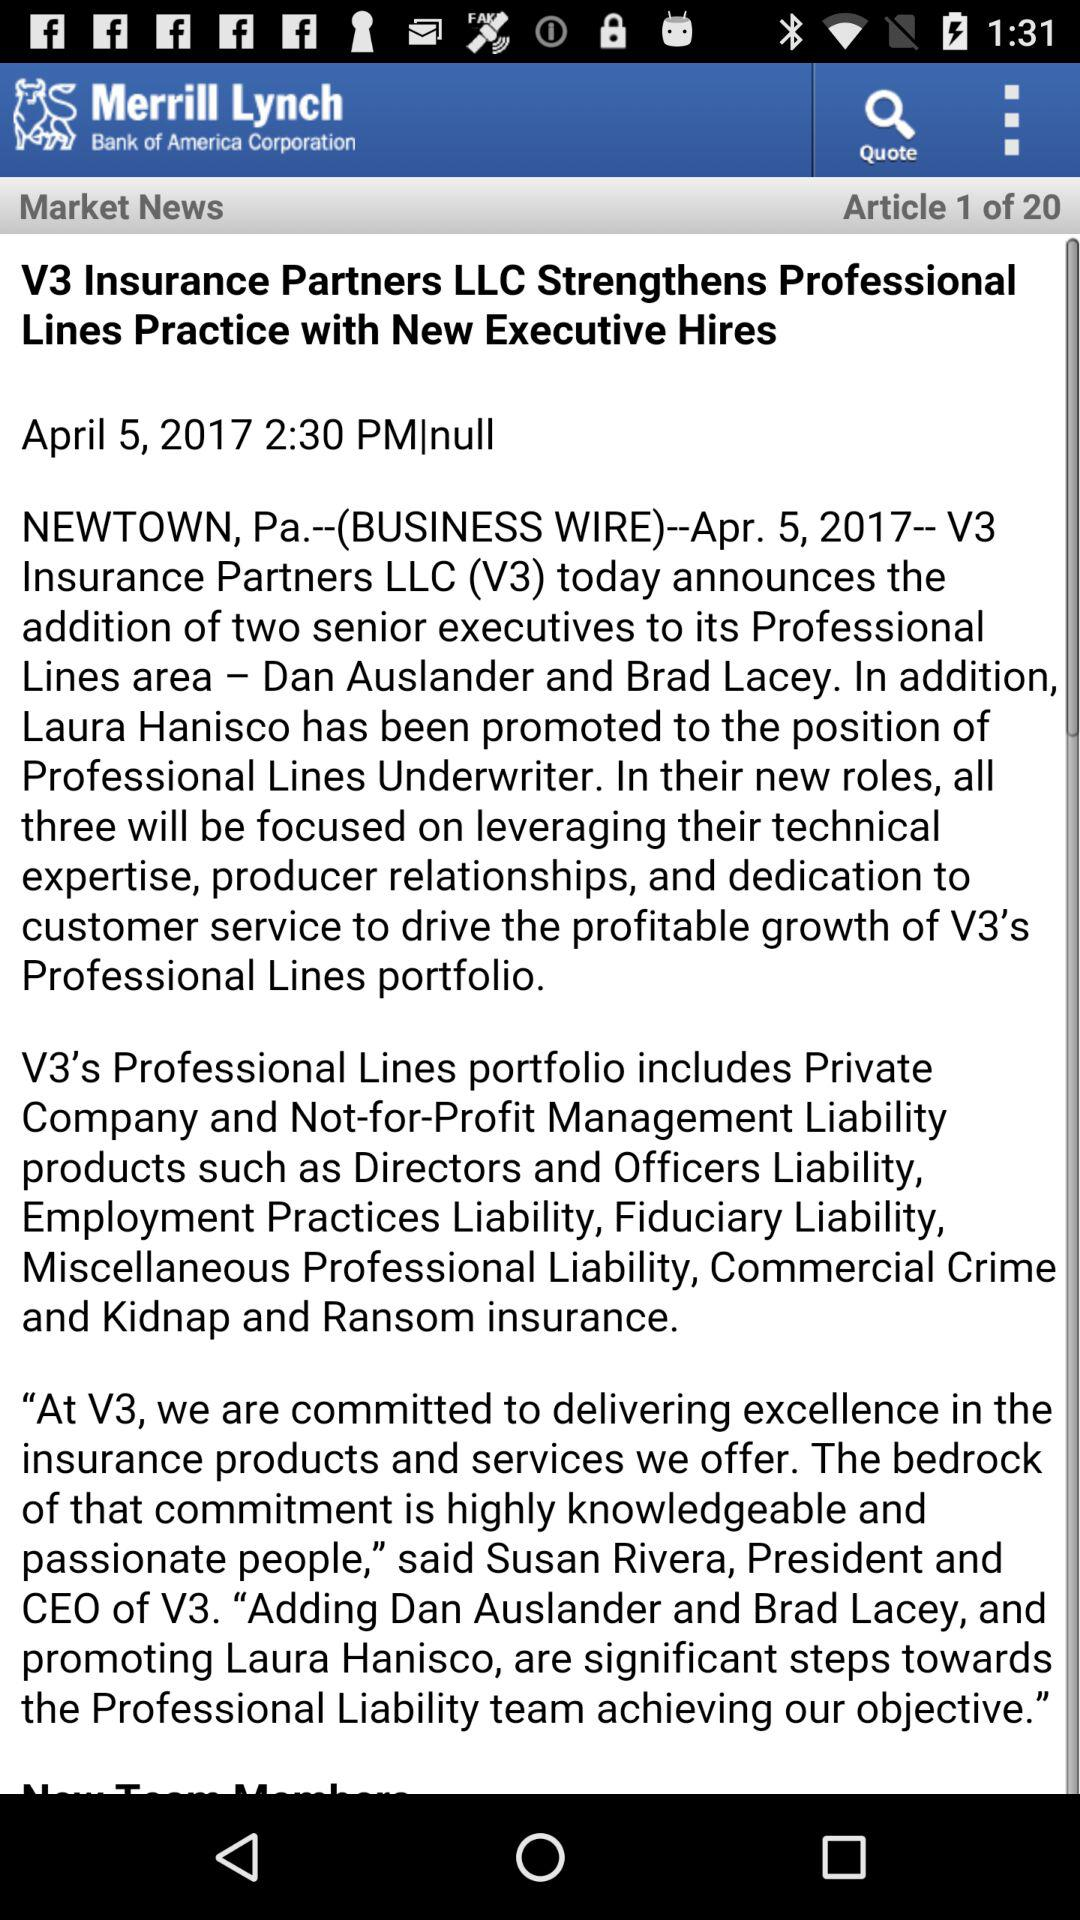In which article are we right now? You are at article 1. 